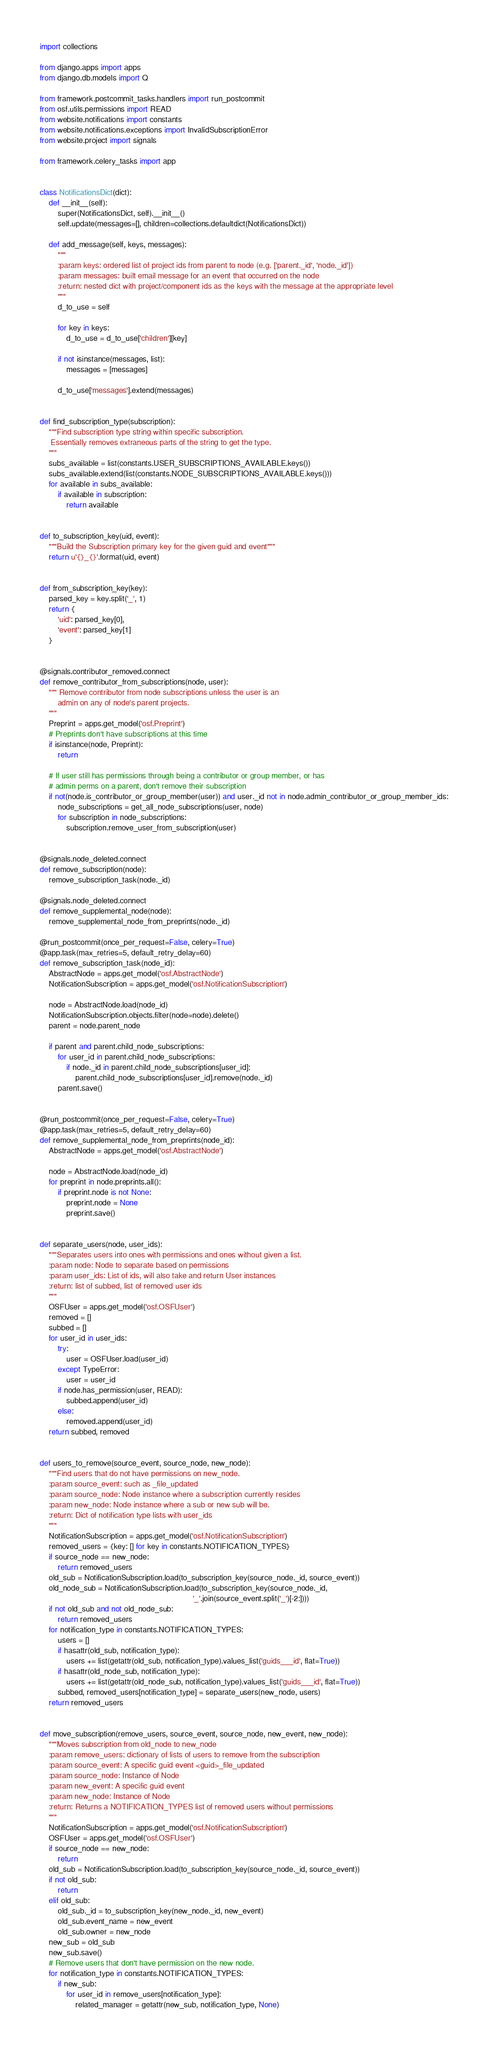Convert code to text. <code><loc_0><loc_0><loc_500><loc_500><_Python_>import collections

from django.apps import apps
from django.db.models import Q

from framework.postcommit_tasks.handlers import run_postcommit
from osf.utils.permissions import READ
from website.notifications import constants
from website.notifications.exceptions import InvalidSubscriptionError
from website.project import signals

from framework.celery_tasks import app


class NotificationsDict(dict):
    def __init__(self):
        super(NotificationsDict, self).__init__()
        self.update(messages=[], children=collections.defaultdict(NotificationsDict))

    def add_message(self, keys, messages):
        """
        :param keys: ordered list of project ids from parent to node (e.g. ['parent._id', 'node._id'])
        :param messages: built email message for an event that occurred on the node
        :return: nested dict with project/component ids as the keys with the message at the appropriate level
        """
        d_to_use = self

        for key in keys:
            d_to_use = d_to_use['children'][key]

        if not isinstance(messages, list):
            messages = [messages]

        d_to_use['messages'].extend(messages)


def find_subscription_type(subscription):
    """Find subscription type string within specific subscription.
     Essentially removes extraneous parts of the string to get the type.
    """
    subs_available = list(constants.USER_SUBSCRIPTIONS_AVAILABLE.keys())
    subs_available.extend(list(constants.NODE_SUBSCRIPTIONS_AVAILABLE.keys()))
    for available in subs_available:
        if available in subscription:
            return available


def to_subscription_key(uid, event):
    """Build the Subscription primary key for the given guid and event"""
    return u'{}_{}'.format(uid, event)


def from_subscription_key(key):
    parsed_key = key.split('_', 1)
    return {
        'uid': parsed_key[0],
        'event': parsed_key[1]
    }


@signals.contributor_removed.connect
def remove_contributor_from_subscriptions(node, user):
    """ Remove contributor from node subscriptions unless the user is an
        admin on any of node's parent projects.
    """
    Preprint = apps.get_model('osf.Preprint')
    # Preprints don't have subscriptions at this time
    if isinstance(node, Preprint):
        return

    # If user still has permissions through being a contributor or group member, or has
    # admin perms on a parent, don't remove their subscription
    if not(node.is_contributor_or_group_member(user)) and user._id not in node.admin_contributor_or_group_member_ids:
        node_subscriptions = get_all_node_subscriptions(user, node)
        for subscription in node_subscriptions:
            subscription.remove_user_from_subscription(user)


@signals.node_deleted.connect
def remove_subscription(node):
    remove_subscription_task(node._id)

@signals.node_deleted.connect
def remove_supplemental_node(node):
    remove_supplemental_node_from_preprints(node._id)

@run_postcommit(once_per_request=False, celery=True)
@app.task(max_retries=5, default_retry_delay=60)
def remove_subscription_task(node_id):
    AbstractNode = apps.get_model('osf.AbstractNode')
    NotificationSubscription = apps.get_model('osf.NotificationSubscription')

    node = AbstractNode.load(node_id)
    NotificationSubscription.objects.filter(node=node).delete()
    parent = node.parent_node

    if parent and parent.child_node_subscriptions:
        for user_id in parent.child_node_subscriptions:
            if node._id in parent.child_node_subscriptions[user_id]:
                parent.child_node_subscriptions[user_id].remove(node._id)
        parent.save()


@run_postcommit(once_per_request=False, celery=True)
@app.task(max_retries=5, default_retry_delay=60)
def remove_supplemental_node_from_preprints(node_id):
    AbstractNode = apps.get_model('osf.AbstractNode')

    node = AbstractNode.load(node_id)
    for preprint in node.preprints.all():
        if preprint.node is not None:
            preprint.node = None
            preprint.save()


def separate_users(node, user_ids):
    """Separates users into ones with permissions and ones without given a list.
    :param node: Node to separate based on permissions
    :param user_ids: List of ids, will also take and return User instances
    :return: list of subbed, list of removed user ids
    """
    OSFUser = apps.get_model('osf.OSFUser')
    removed = []
    subbed = []
    for user_id in user_ids:
        try:
            user = OSFUser.load(user_id)
        except TypeError:
            user = user_id
        if node.has_permission(user, READ):
            subbed.append(user_id)
        else:
            removed.append(user_id)
    return subbed, removed


def users_to_remove(source_event, source_node, new_node):
    """Find users that do not have permissions on new_node.
    :param source_event: such as _file_updated
    :param source_node: Node instance where a subscription currently resides
    :param new_node: Node instance where a sub or new sub will be.
    :return: Dict of notification type lists with user_ids
    """
    NotificationSubscription = apps.get_model('osf.NotificationSubscription')
    removed_users = {key: [] for key in constants.NOTIFICATION_TYPES}
    if source_node == new_node:
        return removed_users
    old_sub = NotificationSubscription.load(to_subscription_key(source_node._id, source_event))
    old_node_sub = NotificationSubscription.load(to_subscription_key(source_node._id,
                                                                     '_'.join(source_event.split('_')[-2:])))
    if not old_sub and not old_node_sub:
        return removed_users
    for notification_type in constants.NOTIFICATION_TYPES:
        users = []
        if hasattr(old_sub, notification_type):
            users += list(getattr(old_sub, notification_type).values_list('guids___id', flat=True))
        if hasattr(old_node_sub, notification_type):
            users += list(getattr(old_node_sub, notification_type).values_list('guids___id', flat=True))
        subbed, removed_users[notification_type] = separate_users(new_node, users)
    return removed_users


def move_subscription(remove_users, source_event, source_node, new_event, new_node):
    """Moves subscription from old_node to new_node
    :param remove_users: dictionary of lists of users to remove from the subscription
    :param source_event: A specific guid event <guid>_file_updated
    :param source_node: Instance of Node
    :param new_event: A specific guid event
    :param new_node: Instance of Node
    :return: Returns a NOTIFICATION_TYPES list of removed users without permissions
    """
    NotificationSubscription = apps.get_model('osf.NotificationSubscription')
    OSFUser = apps.get_model('osf.OSFUser')
    if source_node == new_node:
        return
    old_sub = NotificationSubscription.load(to_subscription_key(source_node._id, source_event))
    if not old_sub:
        return
    elif old_sub:
        old_sub._id = to_subscription_key(new_node._id, new_event)
        old_sub.event_name = new_event
        old_sub.owner = new_node
    new_sub = old_sub
    new_sub.save()
    # Remove users that don't have permission on the new node.
    for notification_type in constants.NOTIFICATION_TYPES:
        if new_sub:
            for user_id in remove_users[notification_type]:
                related_manager = getattr(new_sub, notification_type, None)</code> 